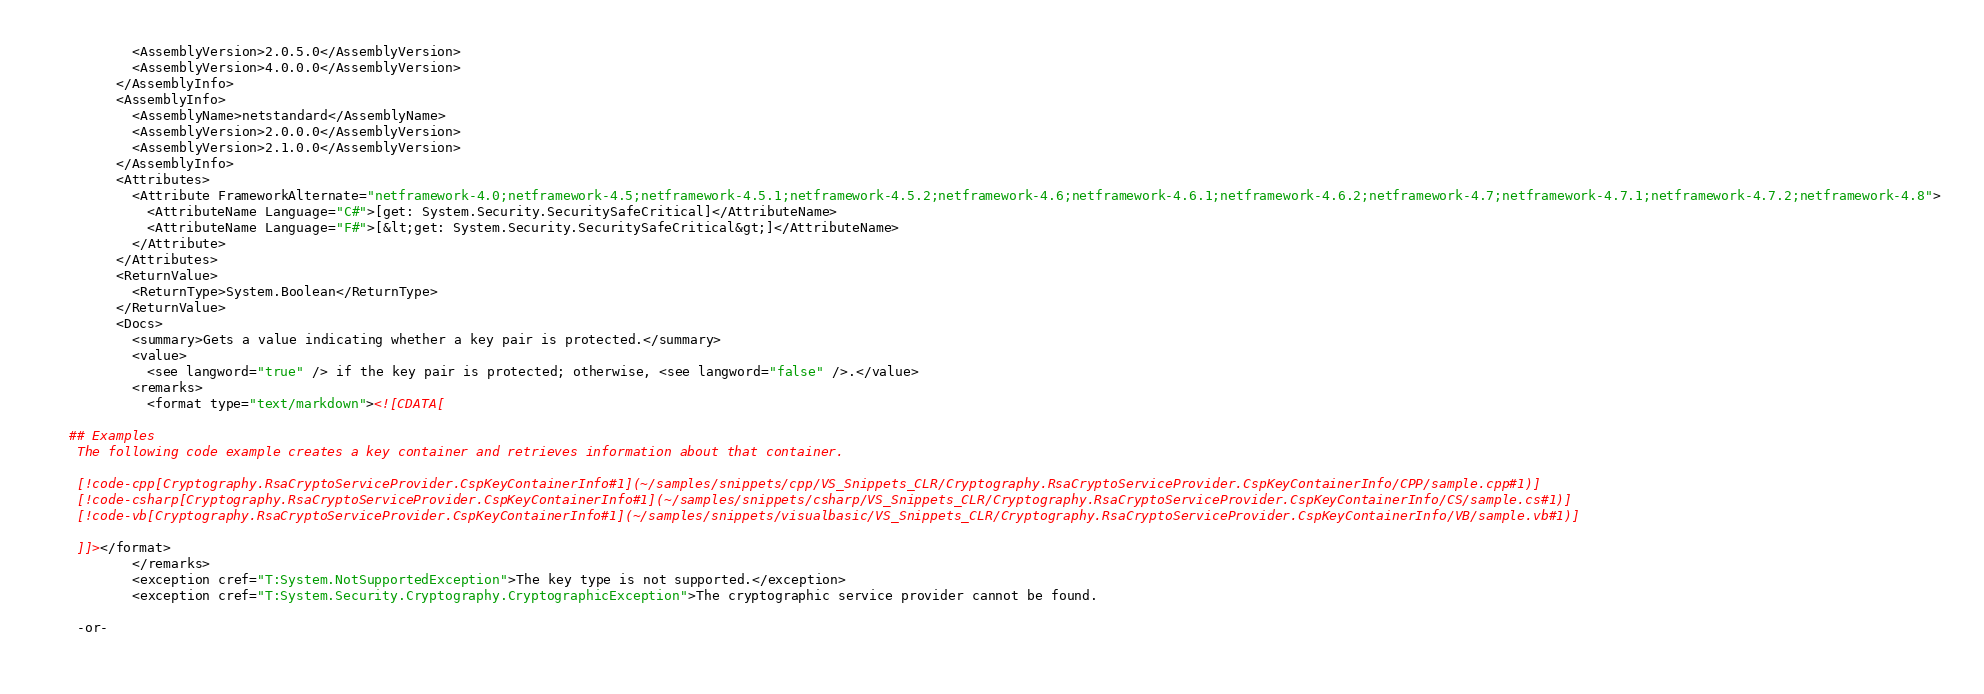<code> <loc_0><loc_0><loc_500><loc_500><_XML_>        <AssemblyVersion>2.0.5.0</AssemblyVersion>
        <AssemblyVersion>4.0.0.0</AssemblyVersion>
      </AssemblyInfo>
      <AssemblyInfo>
        <AssemblyName>netstandard</AssemblyName>
        <AssemblyVersion>2.0.0.0</AssemblyVersion>
        <AssemblyVersion>2.1.0.0</AssemblyVersion>
      </AssemblyInfo>
      <Attributes>
        <Attribute FrameworkAlternate="netframework-4.0;netframework-4.5;netframework-4.5.1;netframework-4.5.2;netframework-4.6;netframework-4.6.1;netframework-4.6.2;netframework-4.7;netframework-4.7.1;netframework-4.7.2;netframework-4.8">
          <AttributeName Language="C#">[get: System.Security.SecuritySafeCritical]</AttributeName>
          <AttributeName Language="F#">[&lt;get: System.Security.SecuritySafeCritical&gt;]</AttributeName>
        </Attribute>
      </Attributes>
      <ReturnValue>
        <ReturnType>System.Boolean</ReturnType>
      </ReturnValue>
      <Docs>
        <summary>Gets a value indicating whether a key pair is protected.</summary>
        <value>
          <see langword="true" /> if the key pair is protected; otherwise, <see langword="false" />.</value>
        <remarks>
          <format type="text/markdown"><![CDATA[  
  
## Examples  
 The following code example creates a key container and retrieves information about that container.  
  
 [!code-cpp[Cryptography.RsaCryptoServiceProvider.CspKeyContainerInfo#1](~/samples/snippets/cpp/VS_Snippets_CLR/Cryptography.RsaCryptoServiceProvider.CspKeyContainerInfo/CPP/sample.cpp#1)]
 [!code-csharp[Cryptography.RsaCryptoServiceProvider.CspKeyContainerInfo#1](~/samples/snippets/csharp/VS_Snippets_CLR/Cryptography.RsaCryptoServiceProvider.CspKeyContainerInfo/CS/sample.cs#1)]
 [!code-vb[Cryptography.RsaCryptoServiceProvider.CspKeyContainerInfo#1](~/samples/snippets/visualbasic/VS_Snippets_CLR/Cryptography.RsaCryptoServiceProvider.CspKeyContainerInfo/VB/sample.vb#1)]  
  
 ]]></format>
        </remarks>
        <exception cref="T:System.NotSupportedException">The key type is not supported.</exception>
        <exception cref="T:System.Security.Cryptography.CryptographicException">The cryptographic service provider cannot be found.  
  
 -or-  
  </code> 